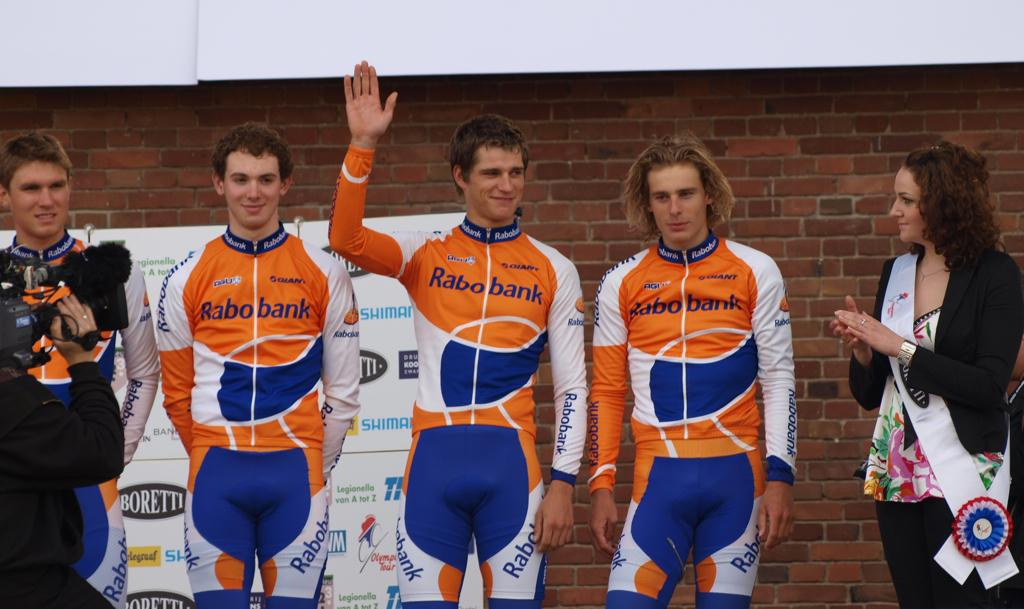Provide a one-sentence caption for the provided image. Rabobank is a sponsor for the athletes in the orange and blue uniforms. 